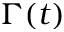<formula> <loc_0><loc_0><loc_500><loc_500>\Gamma ( t )</formula> 